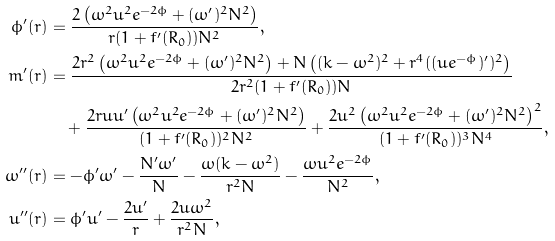Convert formula to latex. <formula><loc_0><loc_0><loc_500><loc_500>\phi ^ { \prime } ( r ) & = \frac { 2 \left ( \omega ^ { 2 } u ^ { 2 } e ^ { - 2 \phi } + ( \omega ^ { \prime } ) ^ { 2 } N ^ { 2 } \right ) } { r ( 1 + f ^ { \prime } ( R _ { 0 } ) ) N ^ { 2 } } , \\ m ^ { \prime } ( r ) & = \frac { 2 r ^ { 2 } \left ( \omega ^ { 2 } u ^ { 2 } e ^ { - 2 \phi } + ( \omega ^ { \prime } ) ^ { 2 } N ^ { 2 } \right ) + N \left ( ( k - \omega ^ { 2 } ) ^ { 2 } + r ^ { 4 } ( ( u e ^ { - \phi } ) ^ { \prime } ) ^ { 2 } \right ) } { 2 r ^ { 2 } ( 1 + f ^ { \prime } ( R _ { 0 } ) ) N } \\ & \quad + \frac { 2 r u u ^ { \prime } \left ( \omega ^ { 2 } u ^ { 2 } e ^ { - 2 \phi } + ( \omega ^ { \prime } ) ^ { 2 } N ^ { 2 } \right ) } { ( 1 + f ^ { \prime } ( R _ { 0 } ) ) ^ { 2 } N ^ { 2 } } + \frac { 2 u ^ { 2 } \left ( \omega ^ { 2 } u ^ { 2 } e ^ { - 2 \phi } + ( \omega ^ { \prime } ) ^ { 2 } N ^ { 2 } \right ) ^ { 2 } } { ( 1 + f ^ { \prime } ( R _ { 0 } ) ) ^ { 3 } N ^ { 4 } } , \\ \omega ^ { \prime \prime } ( r ) & = - \phi ^ { \prime } \omega ^ { \prime } - \frac { N ^ { \prime } \omega ^ { \prime } } { N } - \frac { \omega ( k - \omega ^ { 2 } ) } { r ^ { 2 } N } - \frac { \omega u ^ { 2 } e ^ { - 2 \phi } } { N ^ { 2 } } , \\ u ^ { \prime \prime } ( r ) & = \phi ^ { \prime } u ^ { \prime } - \frac { 2 u ^ { \prime } } { r } + \frac { 2 u \omega ^ { 2 } } { r ^ { 2 } N } ,</formula> 